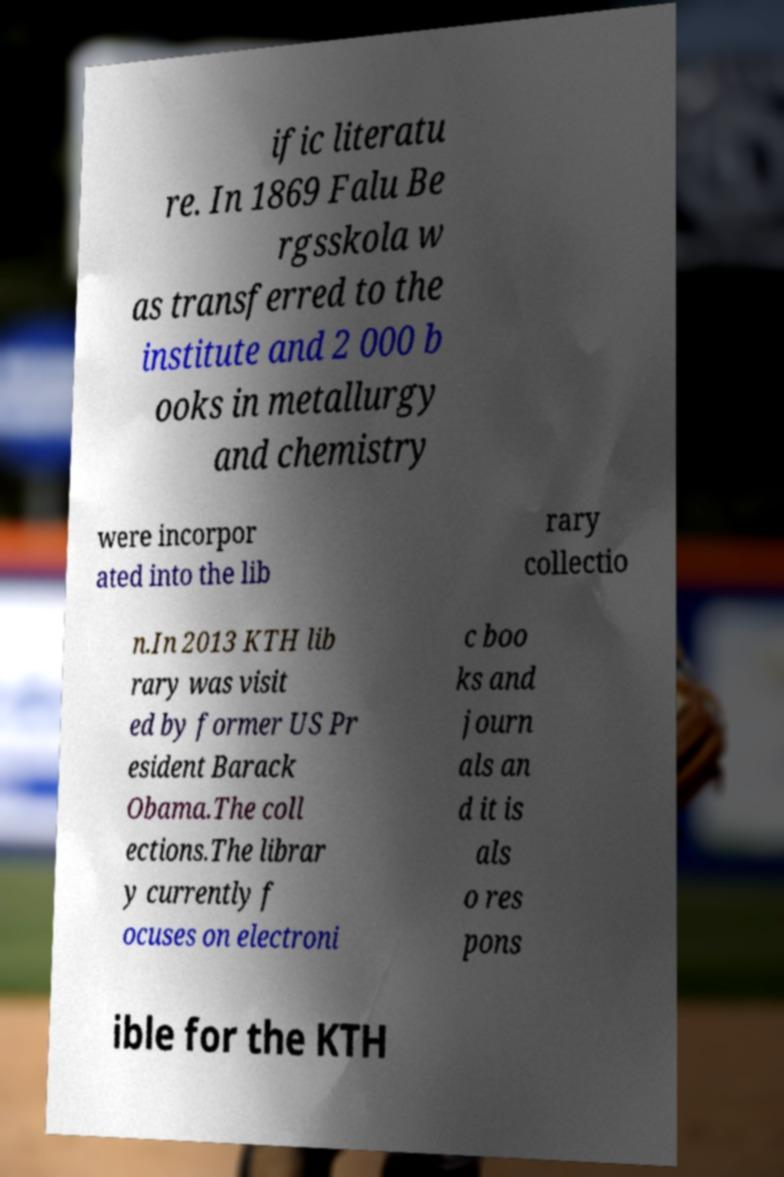Can you read and provide the text displayed in the image?This photo seems to have some interesting text. Can you extract and type it out for me? ific literatu re. In 1869 Falu Be rgsskola w as transferred to the institute and 2 000 b ooks in metallurgy and chemistry were incorpor ated into the lib rary collectio n.In 2013 KTH lib rary was visit ed by former US Pr esident Barack Obama.The coll ections.The librar y currently f ocuses on electroni c boo ks and journ als an d it is als o res pons ible for the KTH 